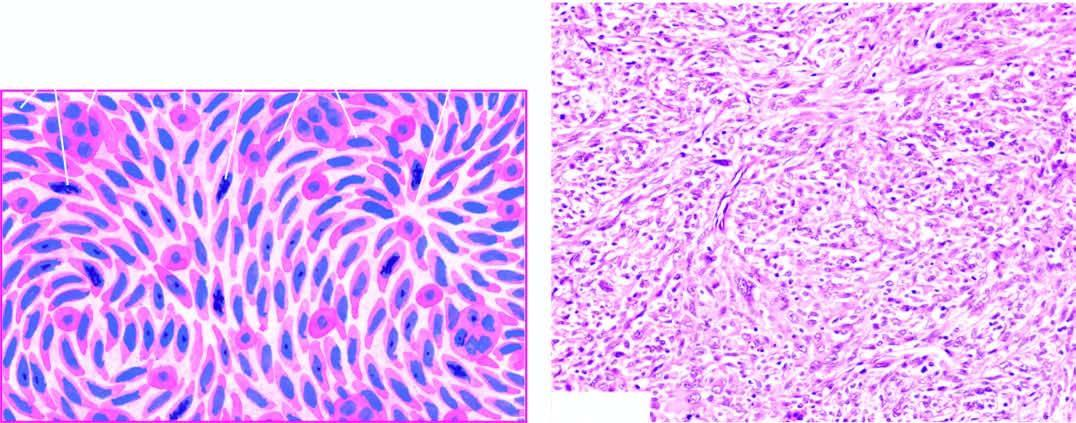does the tumour show admixture of spindle-shaped pleomorphic cells forming storiform pattern and histiocyte-like round to oval cells?
Answer the question using a single word or phrase. Yes 